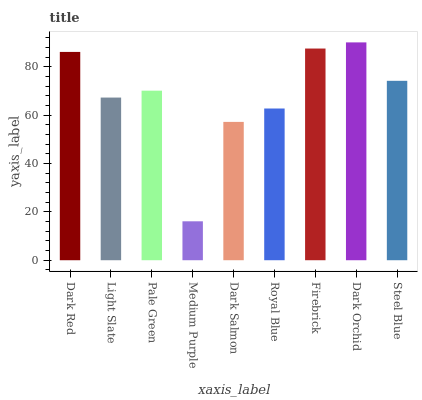Is Light Slate the minimum?
Answer yes or no. No. Is Light Slate the maximum?
Answer yes or no. No. Is Dark Red greater than Light Slate?
Answer yes or no. Yes. Is Light Slate less than Dark Red?
Answer yes or no. Yes. Is Light Slate greater than Dark Red?
Answer yes or no. No. Is Dark Red less than Light Slate?
Answer yes or no. No. Is Pale Green the high median?
Answer yes or no. Yes. Is Pale Green the low median?
Answer yes or no. Yes. Is Dark Orchid the high median?
Answer yes or no. No. Is Dark Orchid the low median?
Answer yes or no. No. 